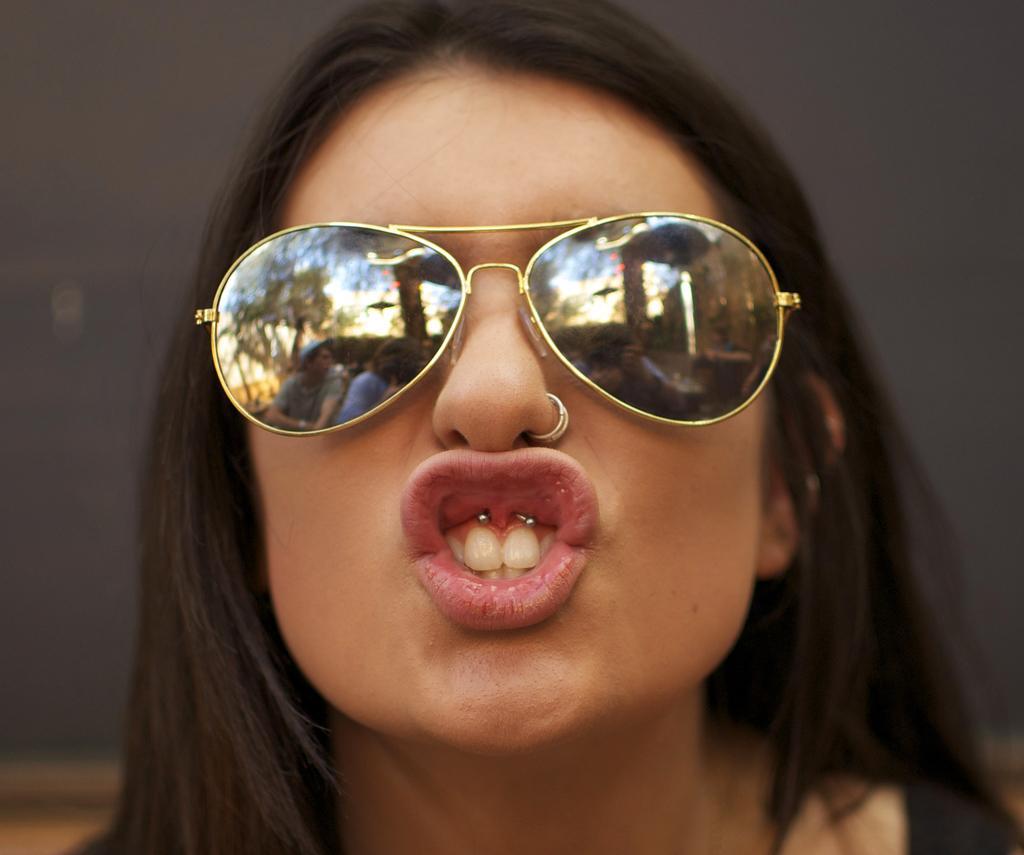How would you summarize this image in a sentence or two? There is a woman wearing goggles. On the lips of the women there are two studs. 